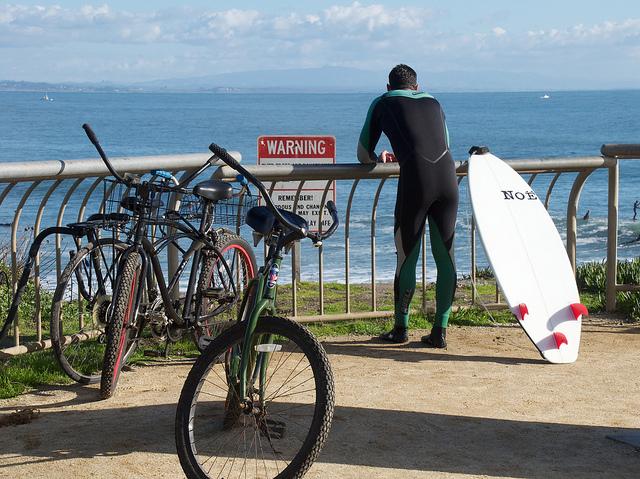Is the bike chained up?
Quick response, please. No. What does the sign say?
Be succinct. Warning. Is this person wearing clothes meant to get wet?
Quick response, please. Yes. 